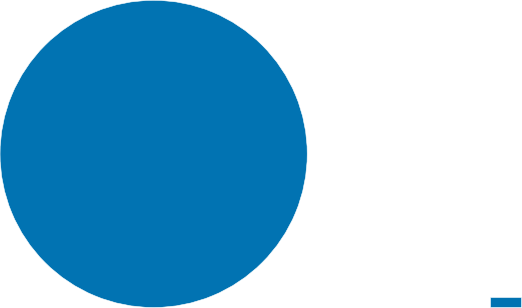Convert chart to OTSL. <chart><loc_0><loc_0><loc_500><loc_500><pie_chart><ecel><nl><fcel>100.0%<nl></chart> 